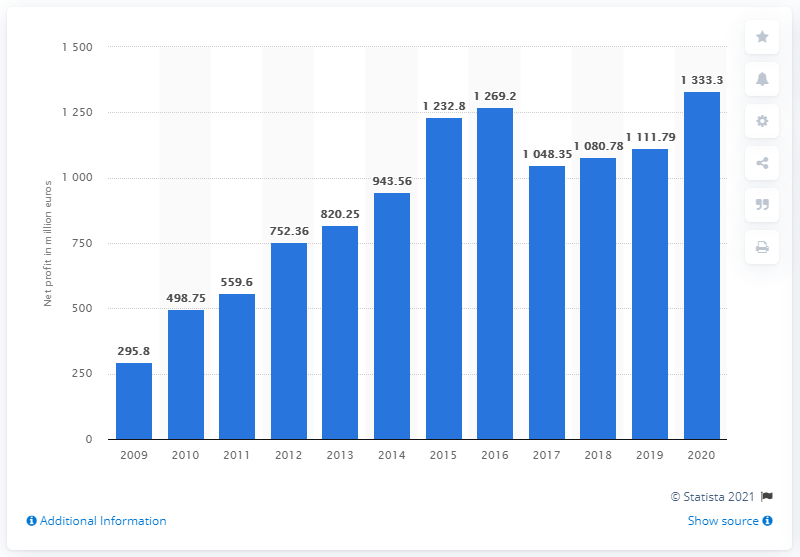Outline some significant characteristics in this image. The Lego Group's net profit in 2020 was approximately 1,333.3 million dollars. 